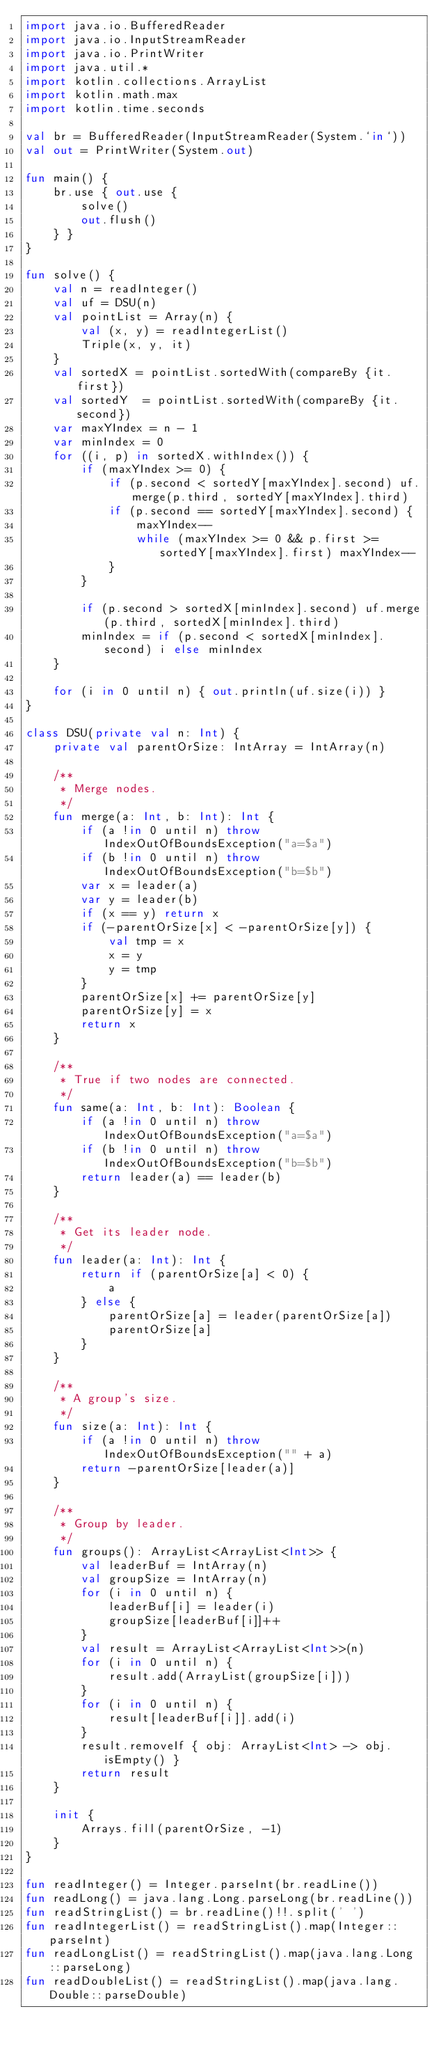<code> <loc_0><loc_0><loc_500><loc_500><_Kotlin_>import java.io.BufferedReader
import java.io.InputStreamReader
import java.io.PrintWriter
import java.util.*
import kotlin.collections.ArrayList
import kotlin.math.max
import kotlin.time.seconds

val br = BufferedReader(InputStreamReader(System.`in`))
val out = PrintWriter(System.out)

fun main() {
    br.use { out.use {
        solve()
        out.flush()
    } }
}

fun solve() {
    val n = readInteger()
    val uf = DSU(n)
    val pointList = Array(n) {
        val (x, y) = readIntegerList()
        Triple(x, y, it)
    }
    val sortedX = pointList.sortedWith(compareBy {it.first})
    val sortedY  = pointList.sortedWith(compareBy {it.second})
    var maxYIndex = n - 1
    var minIndex = 0
    for ((i, p) in sortedX.withIndex()) {
        if (maxYIndex >= 0) {
            if (p.second < sortedY[maxYIndex].second) uf.merge(p.third, sortedY[maxYIndex].third)
            if (p.second == sortedY[maxYIndex].second) {
                maxYIndex--
                while (maxYIndex >= 0 && p.first >= sortedY[maxYIndex].first) maxYIndex--
            }
        }

        if (p.second > sortedX[minIndex].second) uf.merge(p.third, sortedX[minIndex].third)
        minIndex = if (p.second < sortedX[minIndex].second) i else minIndex
    }

    for (i in 0 until n) { out.println(uf.size(i)) }
}

class DSU(private val n: Int) {
    private val parentOrSize: IntArray = IntArray(n)

    /**
     * Merge nodes.
     */
    fun merge(a: Int, b: Int): Int {
        if (a !in 0 until n) throw IndexOutOfBoundsException("a=$a")
        if (b !in 0 until n) throw IndexOutOfBoundsException("b=$b")
        var x = leader(a)
        var y = leader(b)
        if (x == y) return x
        if (-parentOrSize[x] < -parentOrSize[y]) {
            val tmp = x
            x = y
            y = tmp
        }
        parentOrSize[x] += parentOrSize[y]
        parentOrSize[y] = x
        return x
    }

    /**
     * True if two nodes are connected.
     */
    fun same(a: Int, b: Int): Boolean {
        if (a !in 0 until n) throw IndexOutOfBoundsException("a=$a")
        if (b !in 0 until n) throw IndexOutOfBoundsException("b=$b")
        return leader(a) == leader(b)
    }

    /**
     * Get its leader node.
     */
    fun leader(a: Int): Int {
        return if (parentOrSize[a] < 0) {
            a
        } else {
            parentOrSize[a] = leader(parentOrSize[a])
            parentOrSize[a]
        }
    }

    /**
     * A group's size.
     */
    fun size(a: Int): Int {
        if (a !in 0 until n) throw IndexOutOfBoundsException("" + a)
        return -parentOrSize[leader(a)]
    }

    /**
     * Group by leader.
     */
    fun groups(): ArrayList<ArrayList<Int>> {
        val leaderBuf = IntArray(n)
        val groupSize = IntArray(n)
        for (i in 0 until n) {
            leaderBuf[i] = leader(i)
            groupSize[leaderBuf[i]]++
        }
        val result = ArrayList<ArrayList<Int>>(n)
        for (i in 0 until n) {
            result.add(ArrayList(groupSize[i]))
        }
        for (i in 0 until n) {
            result[leaderBuf[i]].add(i)
        }
        result.removeIf { obj: ArrayList<Int> -> obj.isEmpty() }
        return result
    }

    init {
        Arrays.fill(parentOrSize, -1)
    }
}

fun readInteger() = Integer.parseInt(br.readLine())
fun readLong() = java.lang.Long.parseLong(br.readLine())
fun readStringList() = br.readLine()!!.split(' ')
fun readIntegerList() = readStringList().map(Integer::parseInt)
fun readLongList() = readStringList().map(java.lang.Long::parseLong)
fun readDoubleList() = readStringList().map(java.lang.Double::parseDouble)
</code> 